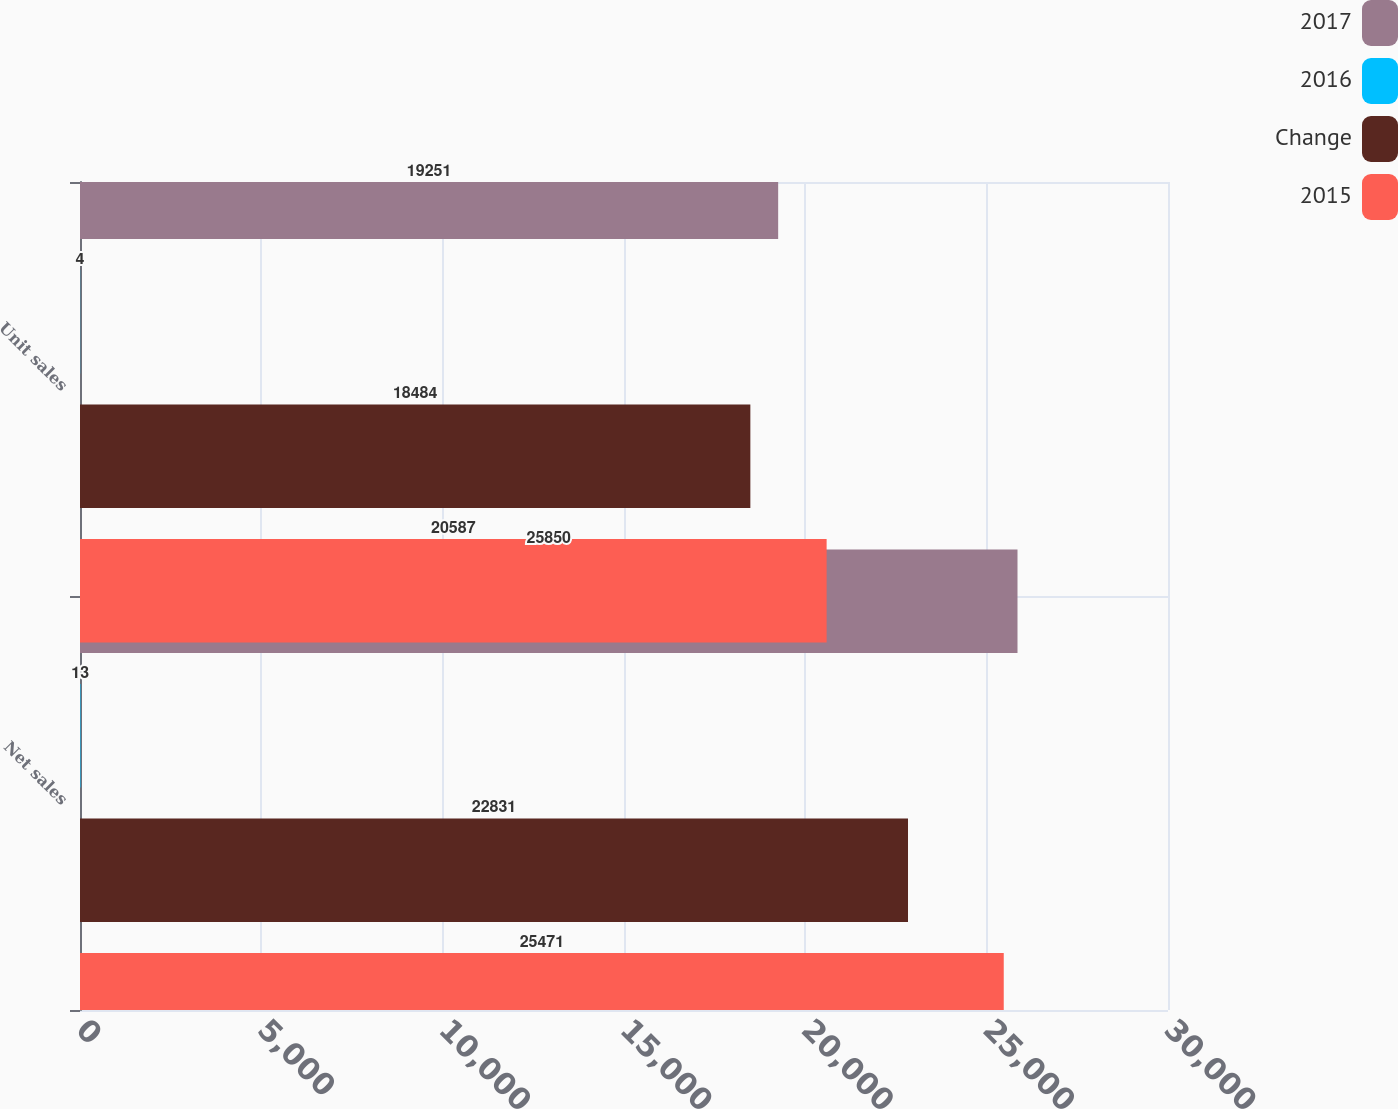<chart> <loc_0><loc_0><loc_500><loc_500><stacked_bar_chart><ecel><fcel>Net sales<fcel>Unit sales<nl><fcel>2017<fcel>25850<fcel>19251<nl><fcel>2016<fcel>13<fcel>4<nl><fcel>Change<fcel>22831<fcel>18484<nl><fcel>2015<fcel>25471<fcel>20587<nl></chart> 